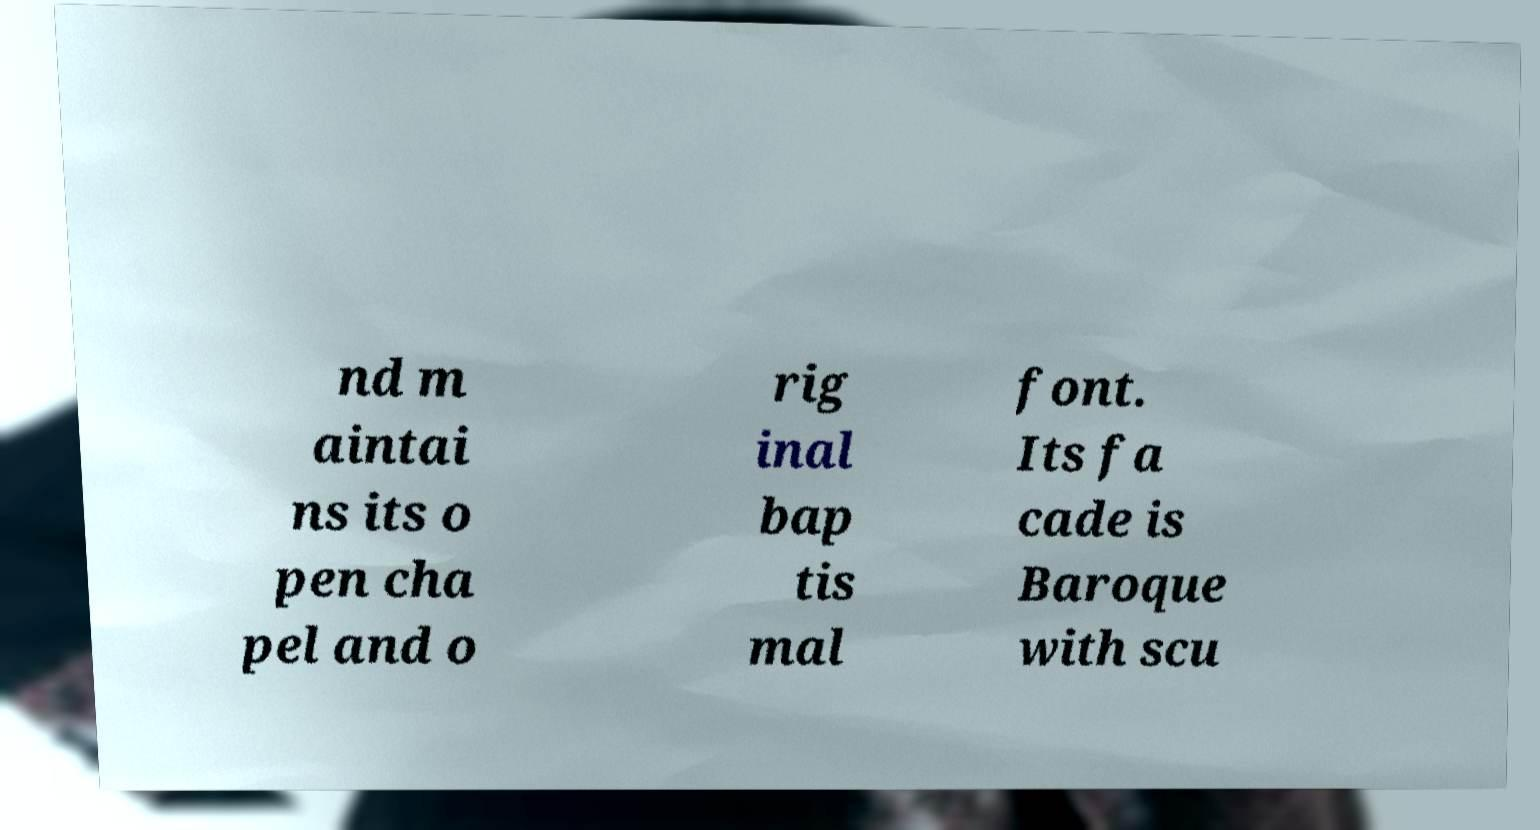For documentation purposes, I need the text within this image transcribed. Could you provide that? nd m aintai ns its o pen cha pel and o rig inal bap tis mal font. Its fa cade is Baroque with scu 